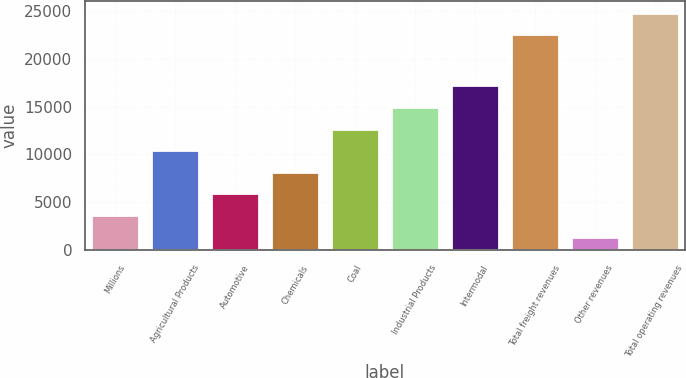<chart> <loc_0><loc_0><loc_500><loc_500><bar_chart><fcel>Millions<fcel>Agricultural Products<fcel>Automotive<fcel>Chemicals<fcel>Coal<fcel>Industrial Products<fcel>Intermodal<fcel>Total freight revenues<fcel>Other revenues<fcel>Total operating revenues<nl><fcel>3684<fcel>10452<fcel>5940<fcel>8196<fcel>12708<fcel>14964<fcel>17220<fcel>22560<fcel>1428<fcel>24816<nl></chart> 